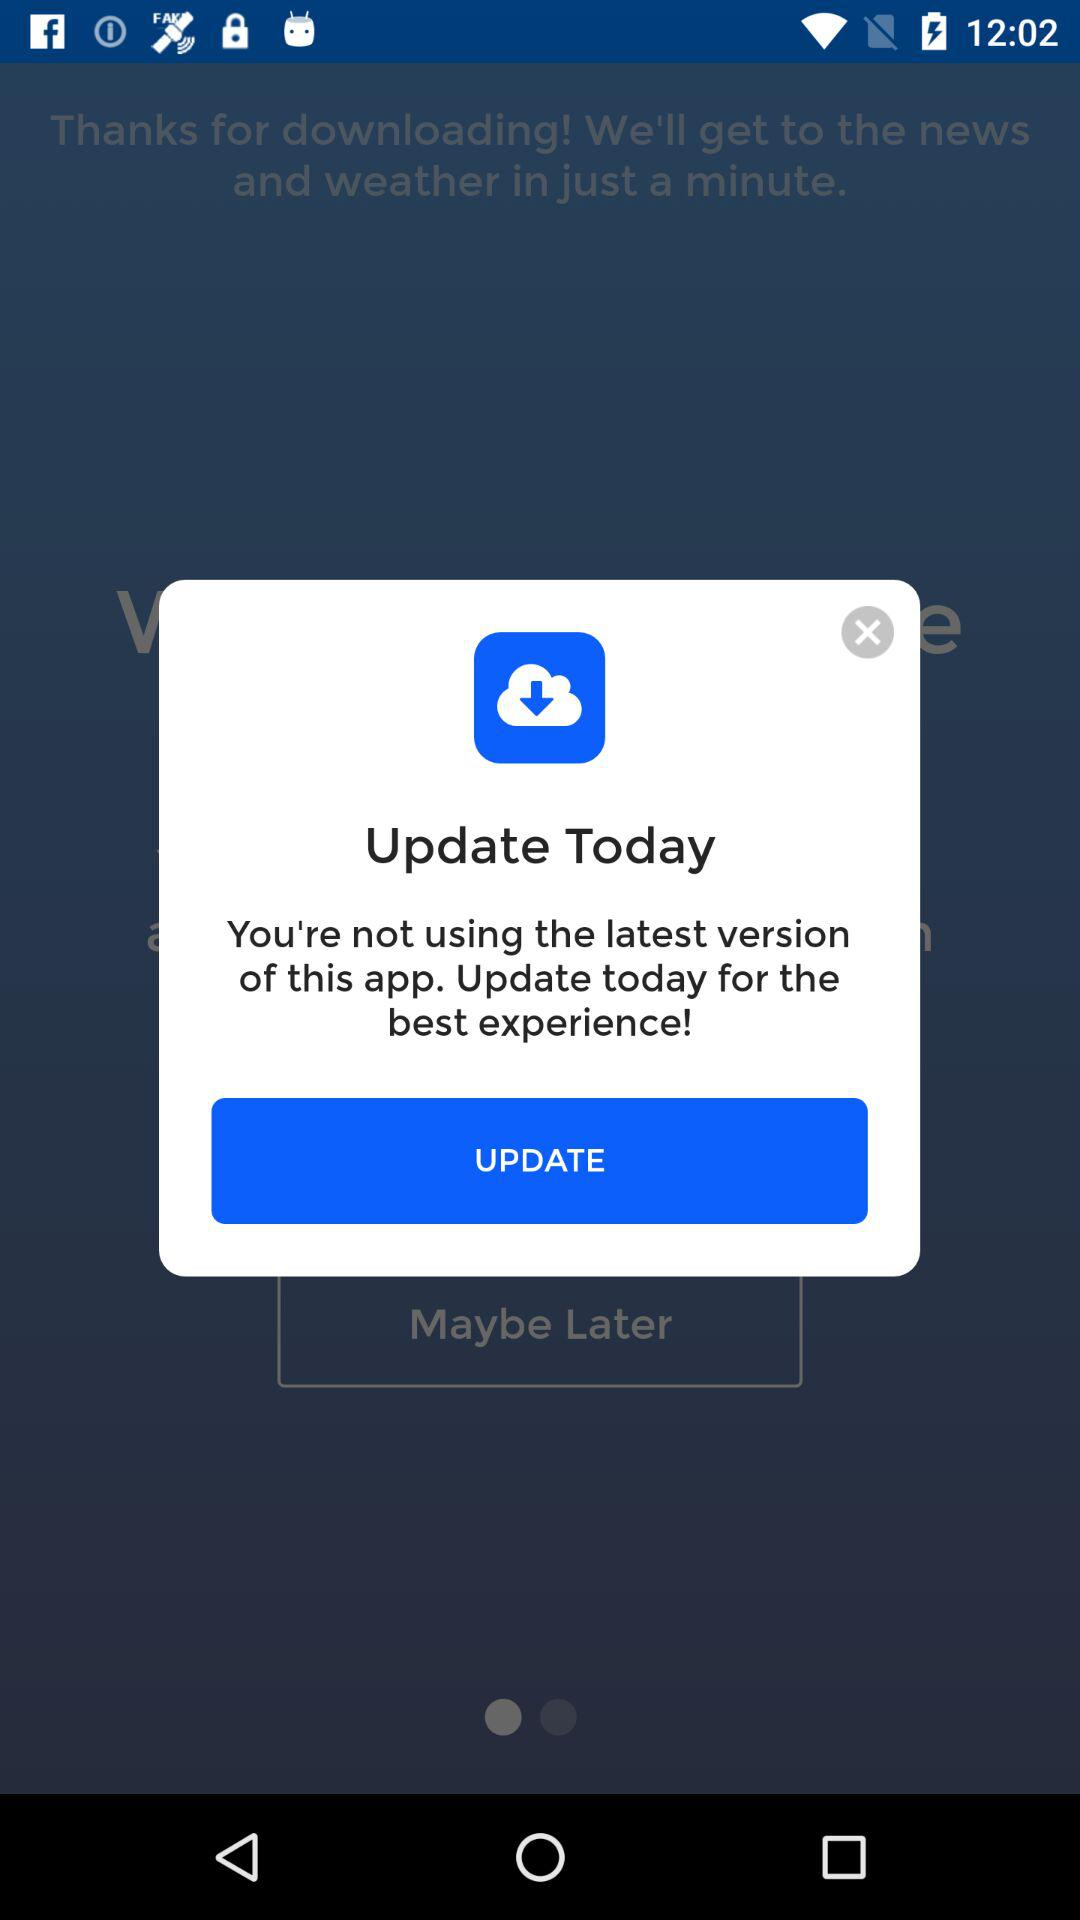What is the application name?
When the provided information is insufficient, respond with <no answer>. <no answer> 